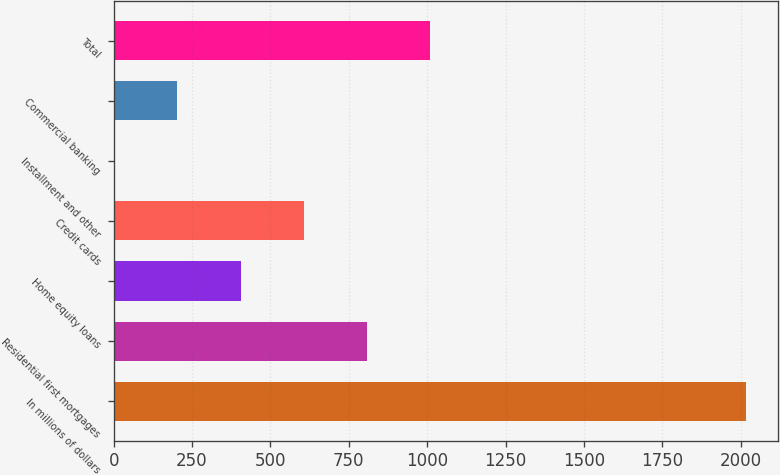Convert chart. <chart><loc_0><loc_0><loc_500><loc_500><bar_chart><fcel>In millions of dollars<fcel>Residential first mortgages<fcel>Home equity loans<fcel>Credit cards<fcel>Installment and other<fcel>Commercial banking<fcel>Total<nl><fcel>2017<fcel>808<fcel>405<fcel>606.5<fcel>2<fcel>203.5<fcel>1009.5<nl></chart> 